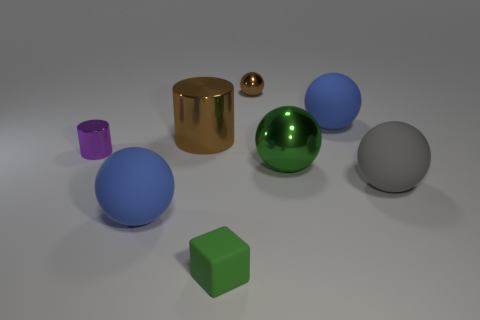There is a matte object that is the same color as the big metal ball; what size is it?
Provide a short and direct response. Small. There is a metal ball behind the large green metallic ball; is it the same color as the big shiny object that is to the left of the small ball?
Ensure brevity in your answer.  Yes. Is there a thing of the same color as the small cube?
Make the answer very short. Yes. Are there any other things that are the same color as the tiny rubber cube?
Provide a short and direct response. Yes. The small thing that is made of the same material as the big gray object is what color?
Offer a terse response. Green. Are there more small green matte objects than big blue rubber things?
Make the answer very short. No. Is there a small red rubber cube?
Provide a short and direct response. No. What is the shape of the large blue rubber object that is behind the gray rubber object that is to the right of the purple metallic thing?
Your answer should be very brief. Sphere. What number of objects are big purple metallic blocks or blue balls in front of the large gray thing?
Offer a very short reply. 1. The big rubber sphere to the left of the blue matte sphere that is behind the sphere on the left side of the big brown metal thing is what color?
Your answer should be very brief. Blue. 